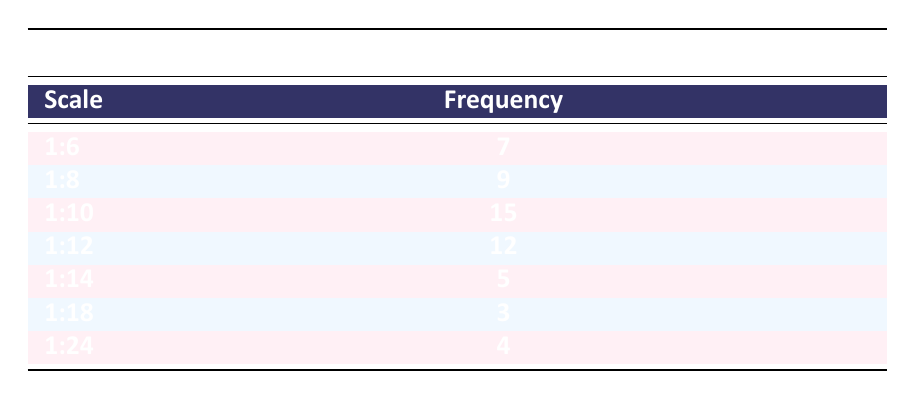What is the frequency of the scale 1:10? The table shows that the frequency for the scale 1:10 is listed directly under the frequency column. It states that the frequency is 15.
Answer: 15 Which scale has the highest frequency? By examining the frequency values listed in the table, the highest frequency is 15, associated with the scale 1:10. Therefore, 1:10 has the highest frequency.
Answer: 1:10 What is the total frequency of all scales combined? To find the total frequency, sum the individual frequencies from each scale: 7 + 9 + 15 + 12 + 5 + 3 + 4 = 55. Thus, the total frequency is 55.
Answer: 55 Is the frequency of scale 1:18 greater than that of scale 1:24? The frequency for scale 1:18 is 3, and for scale 1:24, it is 4. Since 3 is less than 4, the statement is false.
Answer: No How many more models are made at scale 1:12 than at scale 1:8? First, find the frequencies: Scale 1:12 has a frequency of 12, and scale 1:8 has a frequency of 9. Now, calculate the difference: 12 - 9 = 3. Therefore, there are 3 more models made at scale 1:12.
Answer: 3 What is the average frequency of scales 1:6, 1:8, and 1:10? To find the average, first sum the frequencies of these scales: 7 (1:6) + 9 (1:8) + 15 (1:10) = 31. There are 3 scales, so divide the sum by 3: 31 / 3 = 10.33 (approx). The average frequency is about 10.33.
Answer: 10.33 Which scales have a frequency of less than 5? The table shows that only the scale 1:18 has a frequency of 3, and scale 1:14 has a frequency of 5, which does not meet the criteria. So, the only scale with a frequency less than 5 is 1:18.
Answer: 1:18 Is the frequency of scale 1:6 equal to the frequency of scale 1:14? The frequency for scale 1:6 is 7, while the frequency for scale 1:14 is 5. Since these two frequencies are not equal, the statement is false.
Answer: No 